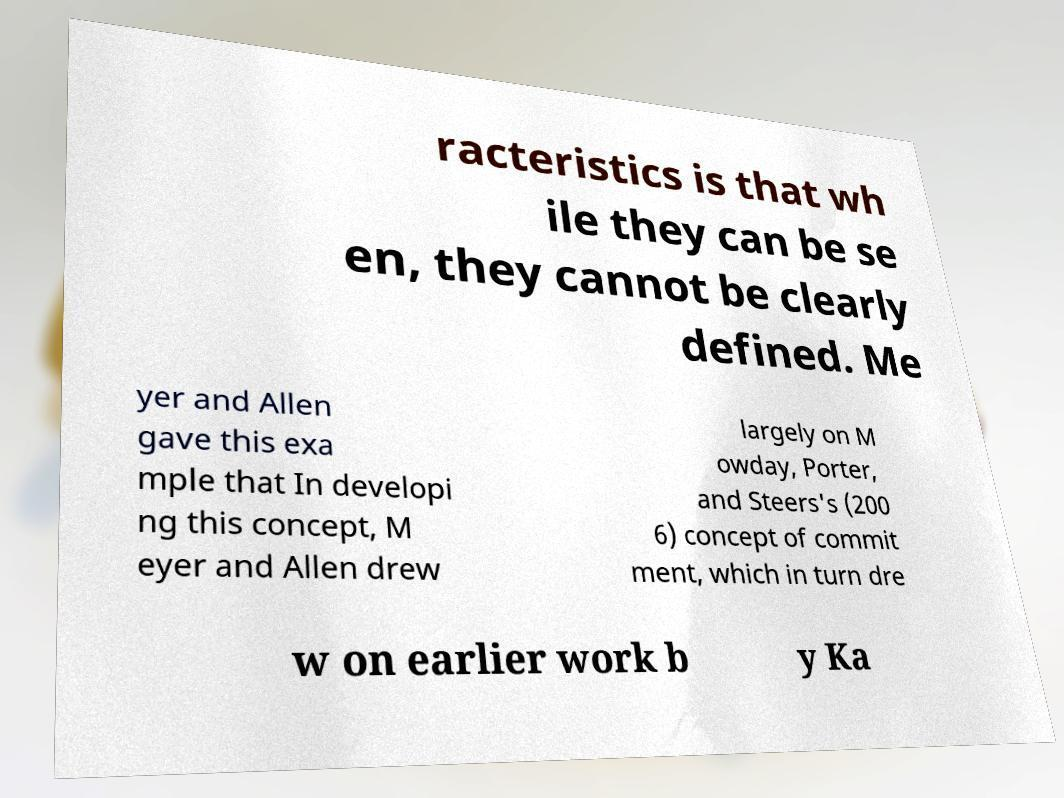There's text embedded in this image that I need extracted. Can you transcribe it verbatim? racteristics is that wh ile they can be se en, they cannot be clearly defined. Me yer and Allen gave this exa mple that In developi ng this concept, M eyer and Allen drew largely on M owday, Porter, and Steers's (200 6) concept of commit ment, which in turn dre w on earlier work b y Ka 